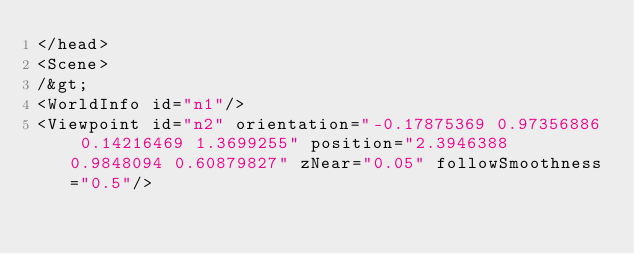<code> <loc_0><loc_0><loc_500><loc_500><_XML_></head>
<Scene>
/&gt;
<WorldInfo id="n1"/>
<Viewpoint id="n2" orientation="-0.17875369 0.97356886 0.14216469 1.3699255" position="2.3946388 0.9848094 0.60879827" zNear="0.05" followSmoothness="0.5"/></code> 